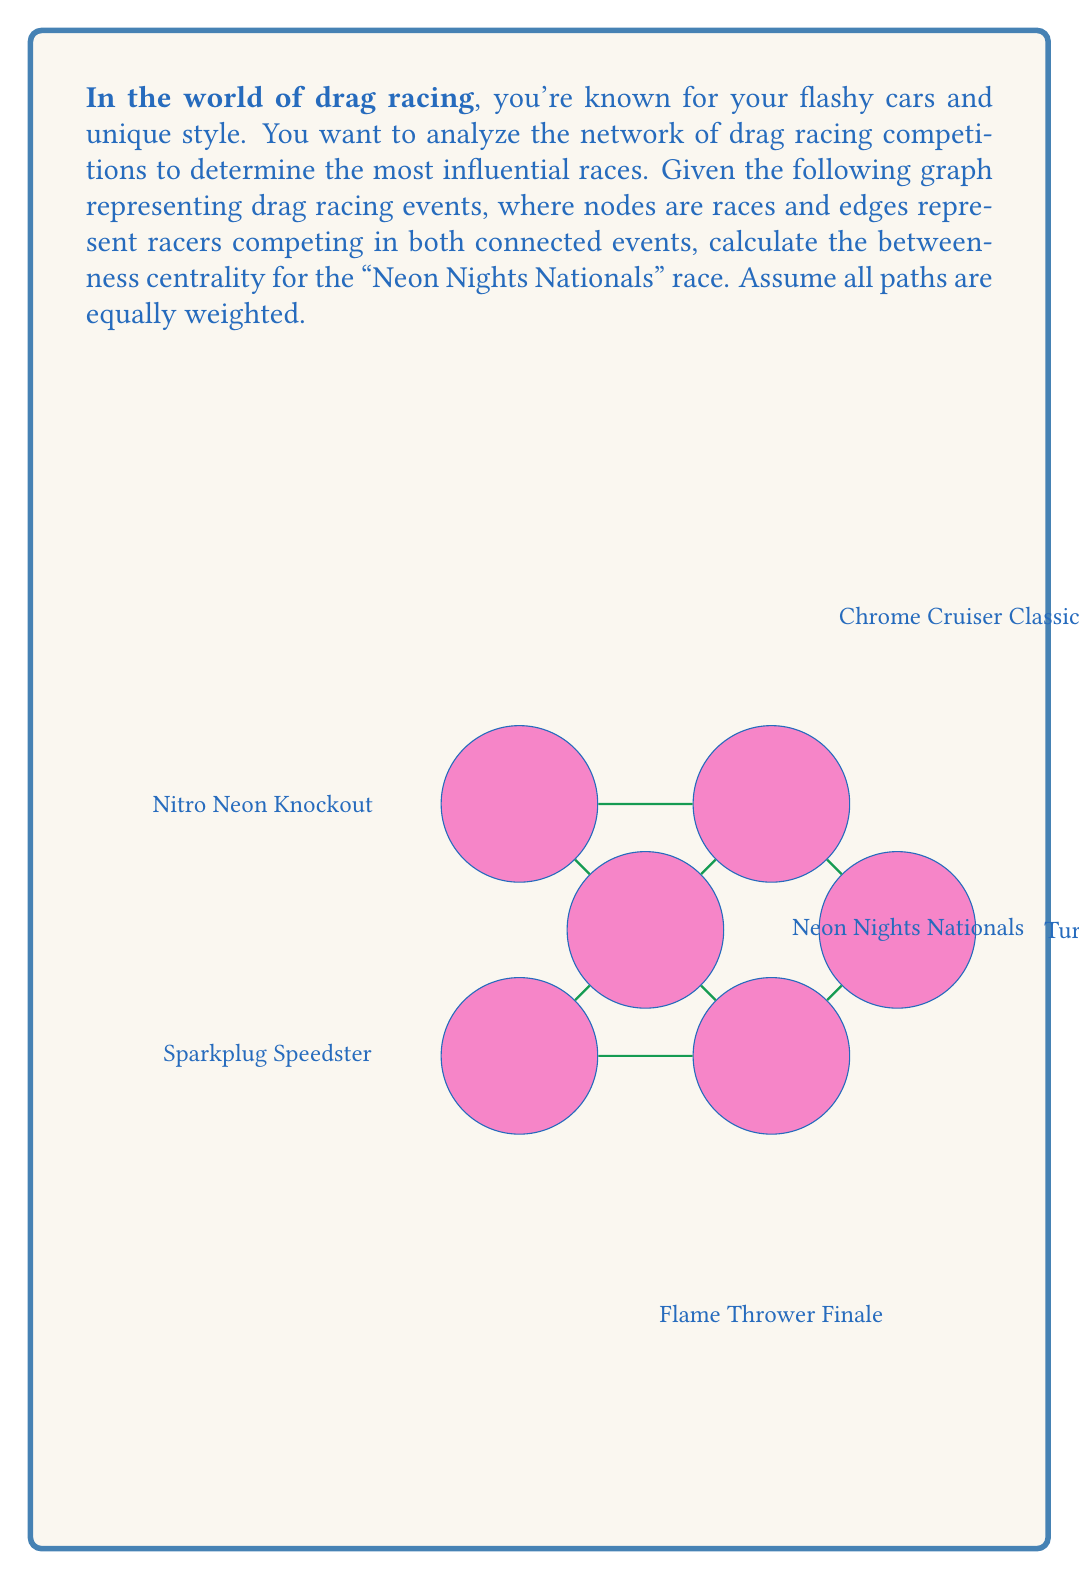Can you solve this math problem? To solve this problem, we need to calculate the betweenness centrality for the "Neon Nights Nationals" race. Betweenness centrality measures the extent to which a node lies on paths between other nodes. It's calculated as:

$$C_B(v) = \sum_{s \neq v \neq t} \frac{\sigma_{st}(v)}{\sigma_{st}}$$

Where $\sigma_{st}$ is the total number of shortest paths from node $s$ to node $t$, and $\sigma_{st}(v)$ is the number of those paths passing through $v$.

Let's calculate this step-by-step:

1) First, identify all pairs of nodes that have a shortest path through "Neon Nights Nationals" (A):

   E-C, E-D, E-F, B-D, B-F, C-E, C-F

2) For each pair, count the total number of shortest paths and how many go through A:

   E-C: 2 paths total, 1 through A
   E-D: 2 paths total, 1 through A
   E-F: 1 path total, 1 through A
   B-D: 2 paths total, 1 through A
   B-F: 1 path total, 1 through A
   C-E: 2 paths total, 1 through A
   C-F: 1 path total, 1 through A

3) Sum the fractions:

   $$C_B(A) = \frac{1}{2} + \frac{1}{2} + \frac{1}{1} + \frac{1}{2} + \frac{1}{1} + \frac{1}{2} + \frac{1}{1} = 4.5$$

Therefore, the betweenness centrality for "Neon Nights Nationals" is 4.5.
Answer: The betweenness centrality for the "Neon Nights Nationals" race is 4.5. 